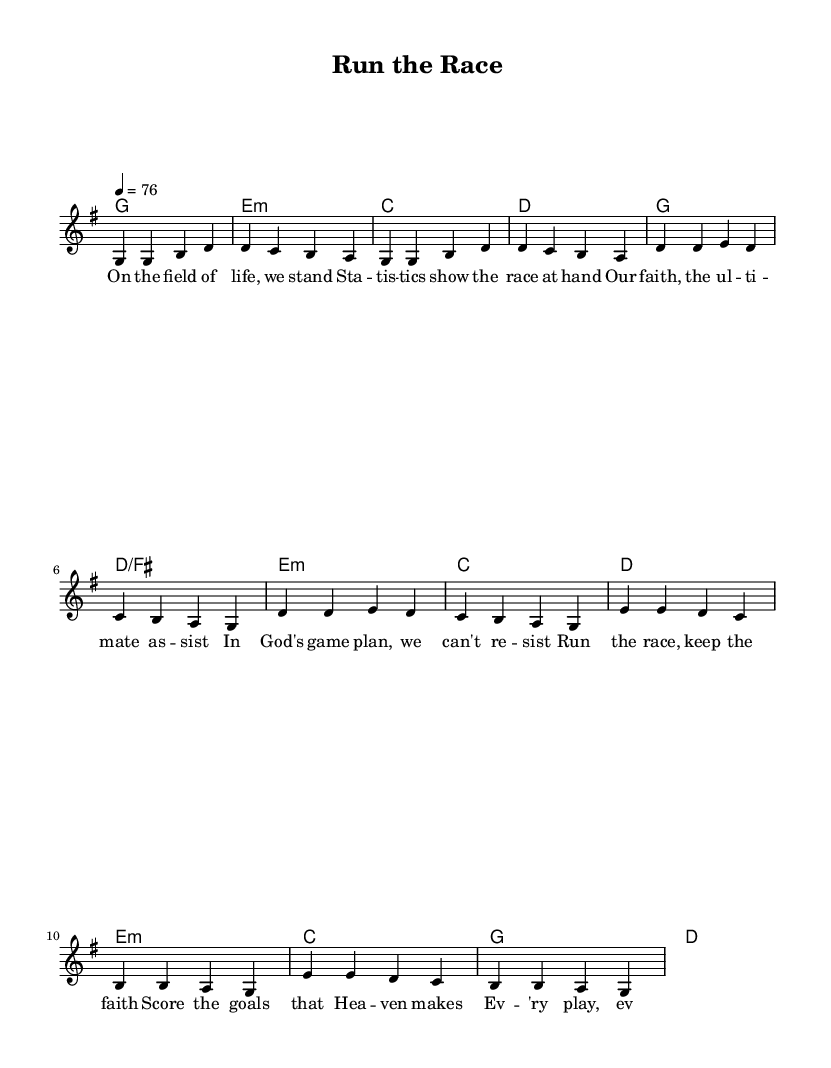What is the key signature of this music? The key signature is G major, which has one sharp. This can be identified by looking at the key indication at the beginning of the score.
Answer: G major What is the time signature of this music? The time signature is 4/4, meaning there are four beats in each measure and the quarter note gets one beat. This is indicated at the beginning of the score right next to the key signature.
Answer: 4/4 What is the tempo marking for this music? The tempo marking is "4 = 76", indicating that a quarter note should be played at a speed of 76 beats per minute. This information is provided in the tempo indication within the global settings of the score.
Answer: 76 How many verses are in this piece? There is one verse presented before the chorus in the score. The structure is organized with the verse followed by the chorus and then a bridge, allowing us to determine the presence of just one verse in the song.
Answer: One What chord is played during the chorus? The chorus utilizes the chords G, D over F-sharp, E minor, C, and D. This can be derived from looking at the chord symbols listed above the lyrics in the chorus section of the score.
Answer: G, D over F-sharp, E minor, C, D What theme is reflected through the lyrics of the song? The theme of athletics and competition is prevalent, emphasized by phrases like "run the race" and "press on towards the goal." This can be gathered by analyzing the lyrics printed below the melody throughout the song.
Answer: Athletics and competition In which part of the song would the lyrics mention "Jesus"? The name "Jesus" appears in the bridge of the song, specifically in the last line of the bridge lyrics, where it mentions "With Jesus, our captain within." This reference can be confirmed by locating the specific lyrics in the bridge section of the score.
Answer: Bridge 